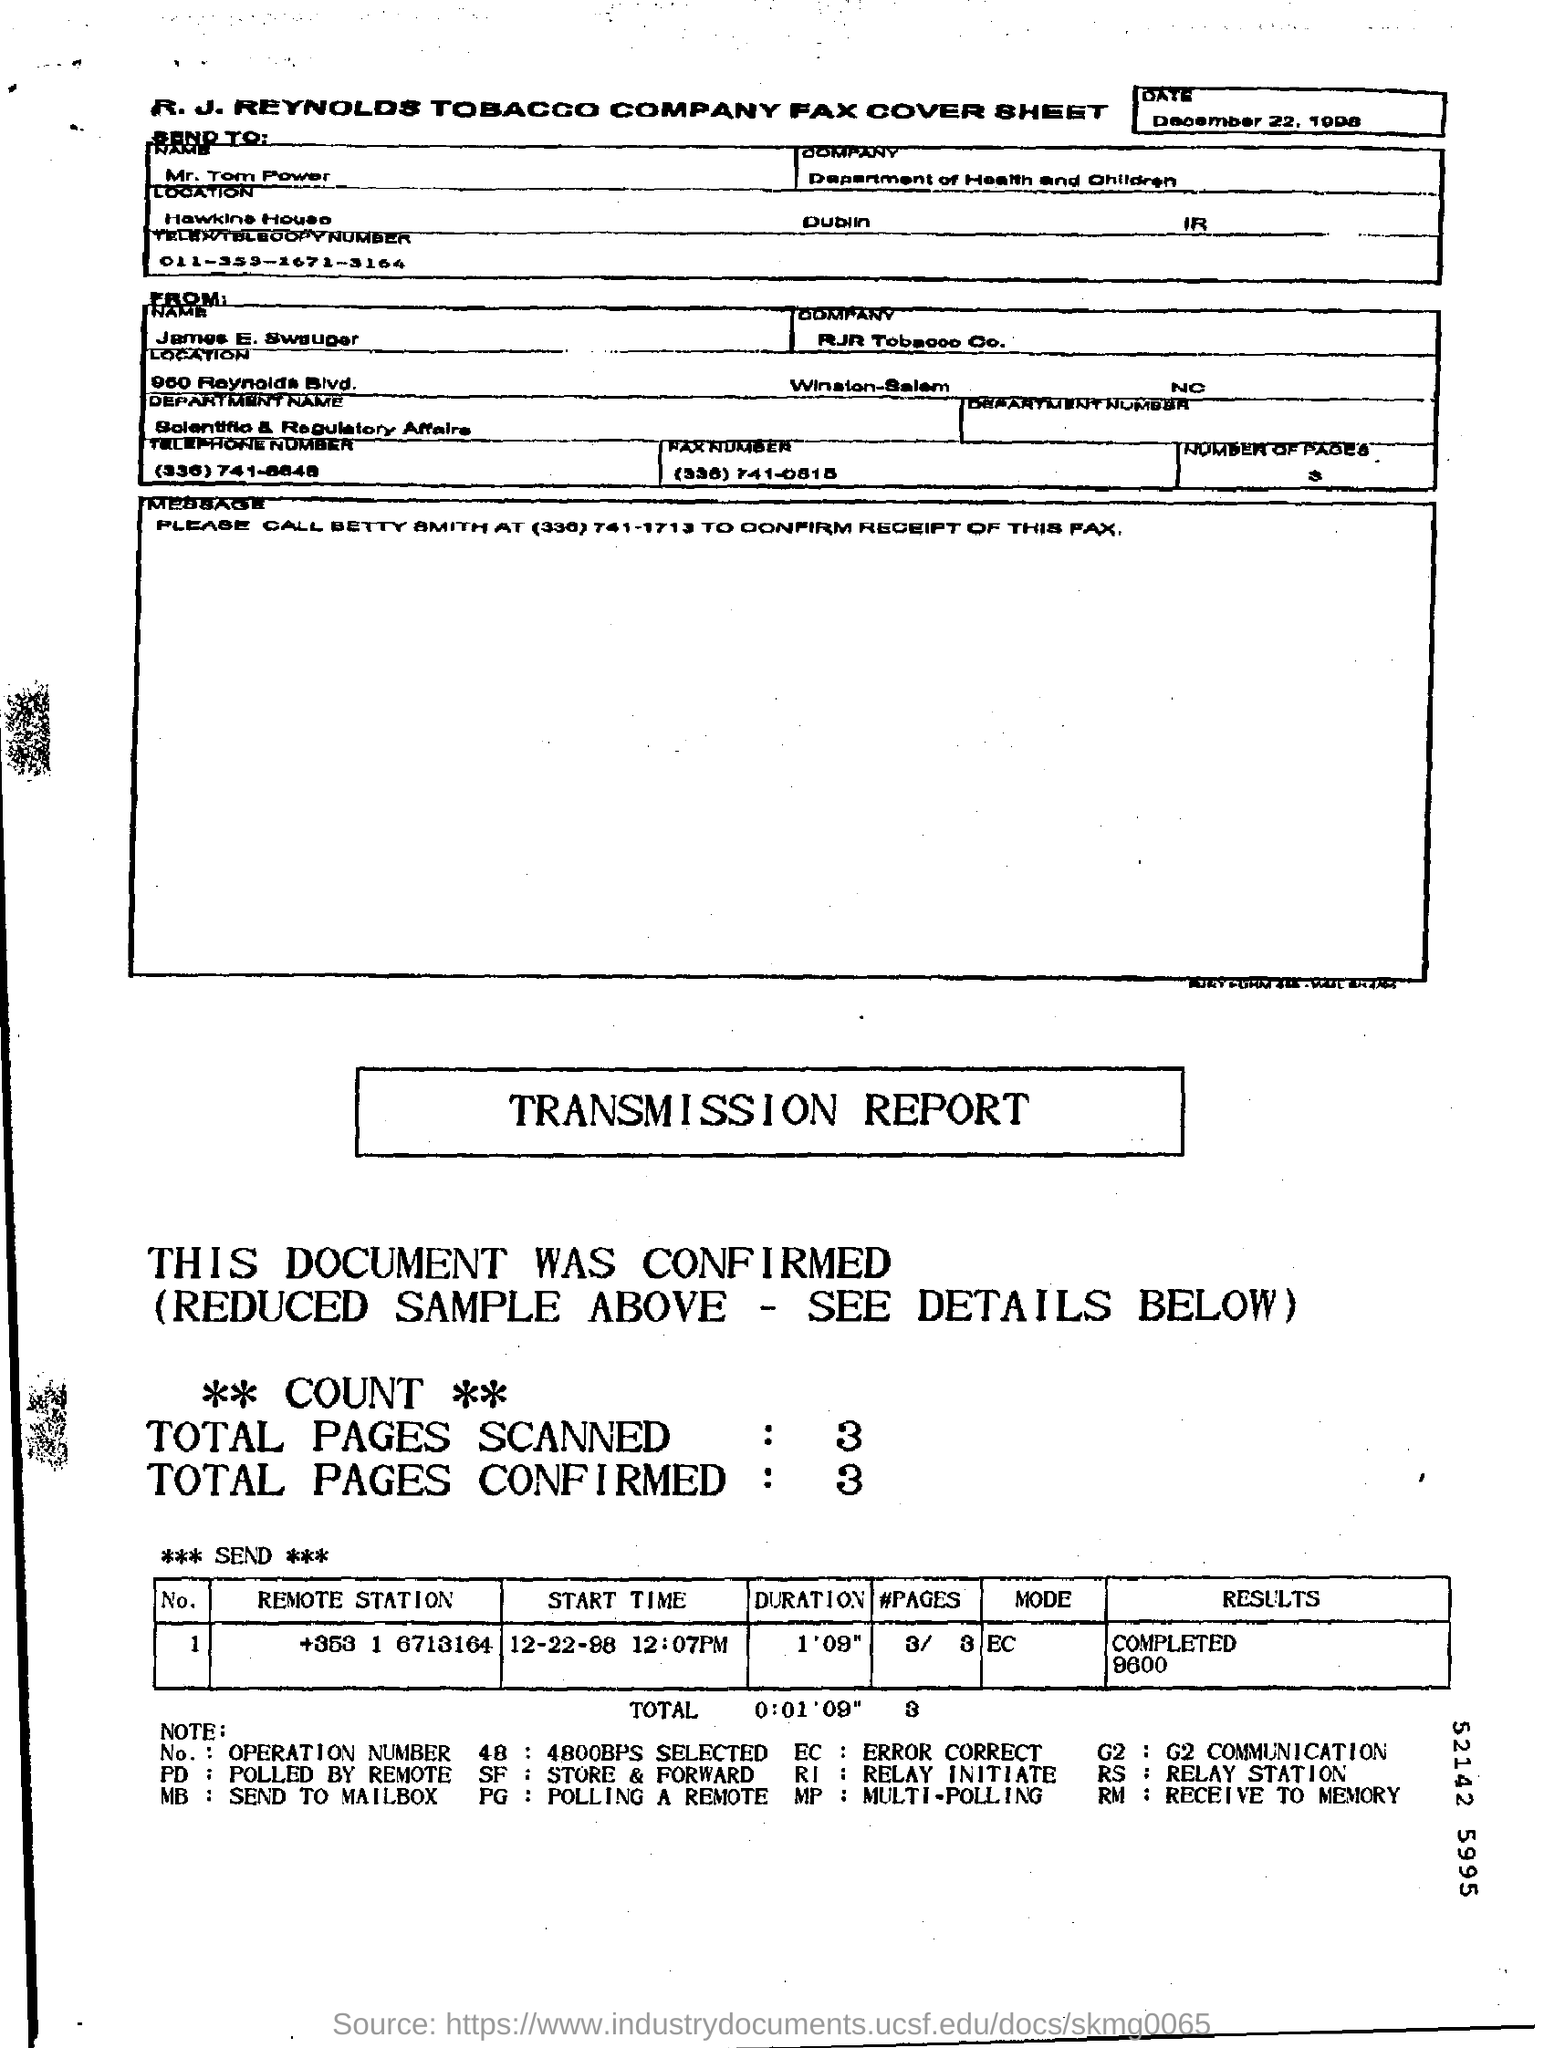Which city in Ireland is mentioned in the "Location" field?
Your answer should be very brief. Dublin. What is the Send To "NAME"?
Keep it short and to the point. Mr. Tom Power. What is the Send To "Company"?
Offer a terse response. Department of Health and Children. Who is this from?
Offer a terse response. James E. Swauger. What is the "Results" for "Remote station" "+353 1 6713164"?
Your answer should be very brief. COMPLETED 9600. What is the "Duration" for "Remote station" "+353 1 6713164"?
Your response must be concise. 1'09". What is the "Start Time" for "Remote station" "+353 1 6713164"?
Offer a very short reply. 12-22-98 12:07PM. What is the "Mode" for "Remote station" "+353 1 6713164"?
Offer a terse response. EC. What are the Total Pages Scanned?
Your answer should be very brief. 3. What are the Total Pages Confirmed?
Give a very brief answer. 3. 